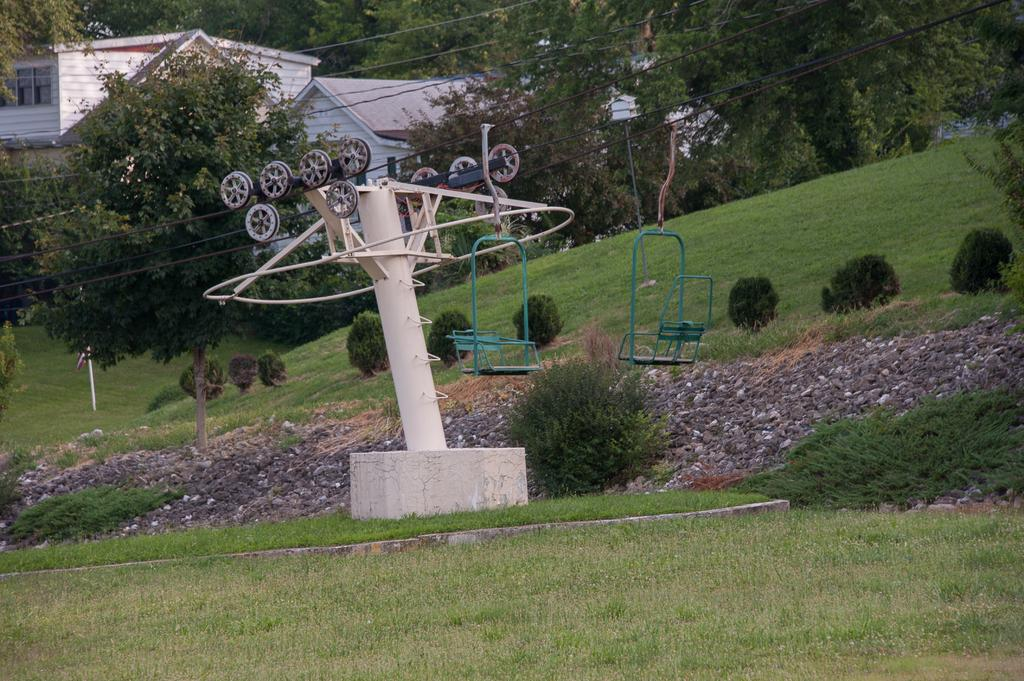What type of vehicle is in the image? There is a rope car in the image. What is the ground surface like in the image? Grass is visible on the ground. What type of natural elements can be seen in the image? There are trees in the image. What type of man-made structures are present in the image? There are buildings in the image. What type of vegetation is present in the image? Plants are present in the image. What are the chairs used for in the image? The chairs are hanging from the rope in the image. What type of army is marching along the route in the image? There is no army or route present in the image; it features a rope car, grass, trees, buildings, plants, and chairs hanging from the rope. Can you tell me how many goats are grazing on the plants in the image? There are no goats present in the image; it features a rope car, grass, trees, buildings, plants, and chairs hanging from the rope. 